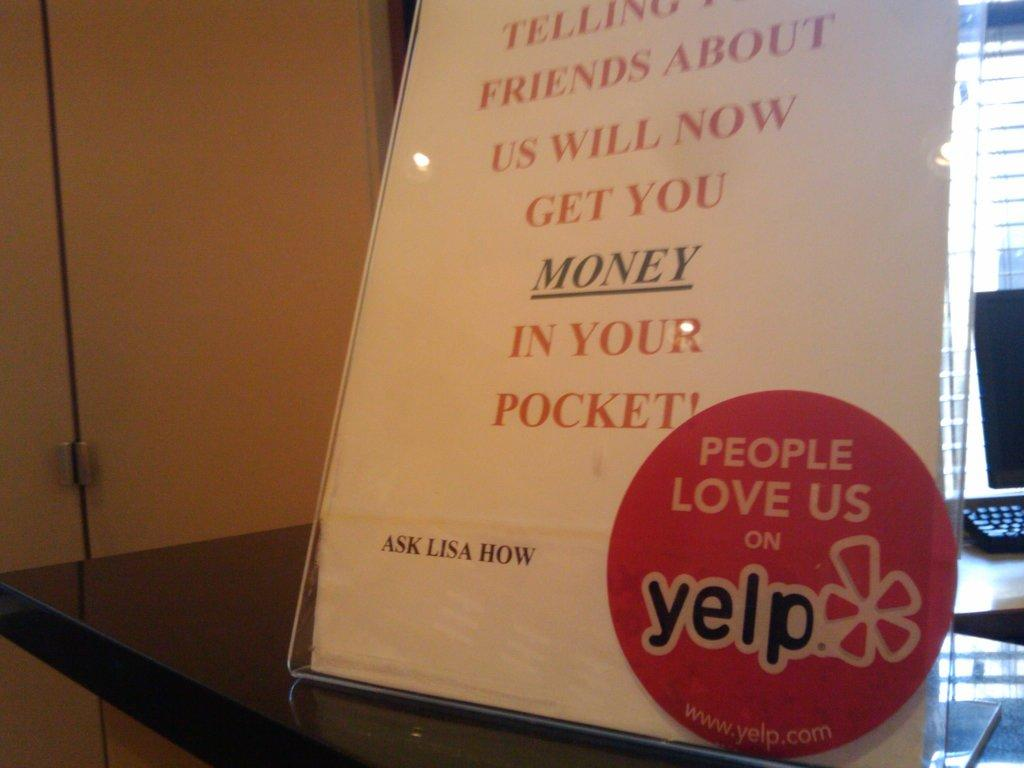<image>
Create a compact narrative representing the image presented. A sign is shown with and ad for Yelp in the corner. 